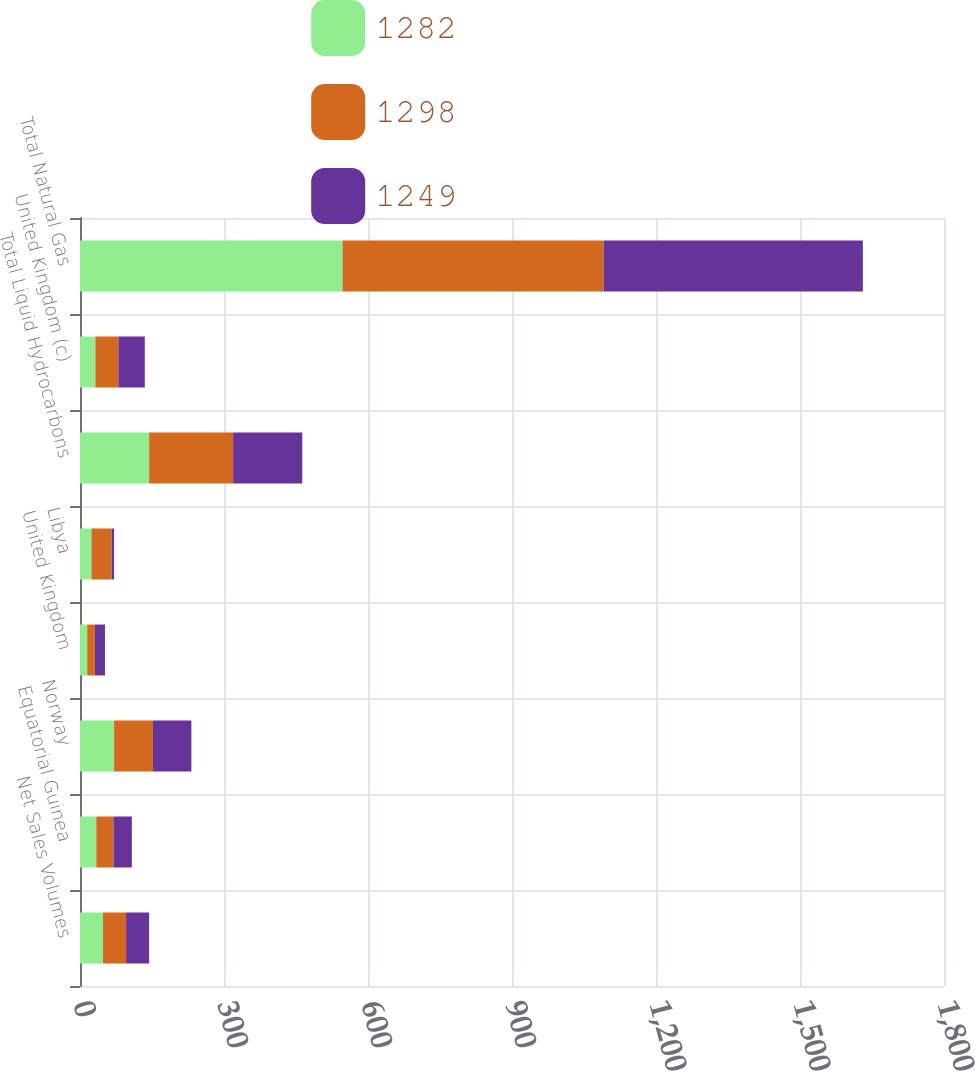Convert chart. <chart><loc_0><loc_0><loc_500><loc_500><stacked_bar_chart><ecel><fcel>Net Sales Volumes<fcel>Equatorial Guinea<fcel>Norway<fcel>United Kingdom<fcel>Libya<fcel>Total Liquid Hydrocarbons<fcel>United Kingdom (c)<fcel>Total Natural Gas<nl><fcel>1282<fcel>48<fcel>34<fcel>71<fcel>15<fcel>24<fcel>144<fcel>32<fcel>547<nl><fcel>1298<fcel>48<fcel>36<fcel>81<fcel>16<fcel>42<fcel>175<fcel>48<fcel>544<nl><fcel>1249<fcel>48<fcel>38<fcel>80<fcel>21<fcel>5<fcel>144<fcel>55<fcel>540<nl></chart> 